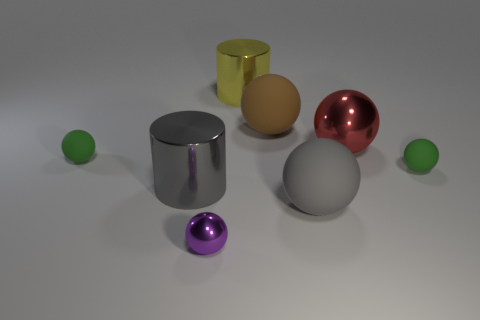Subtract all gray balls. How many balls are left? 5 Subtract all tiny matte balls. How many balls are left? 4 Subtract all gray spheres. Subtract all cyan cubes. How many spheres are left? 5 Add 1 tiny rubber balls. How many objects exist? 9 Subtract all cylinders. How many objects are left? 6 Add 4 yellow metal cylinders. How many yellow metal cylinders are left? 5 Add 7 large brown matte objects. How many large brown matte objects exist? 8 Subtract 0 red cylinders. How many objects are left? 8 Subtract all tiny spheres. Subtract all shiny cylinders. How many objects are left? 3 